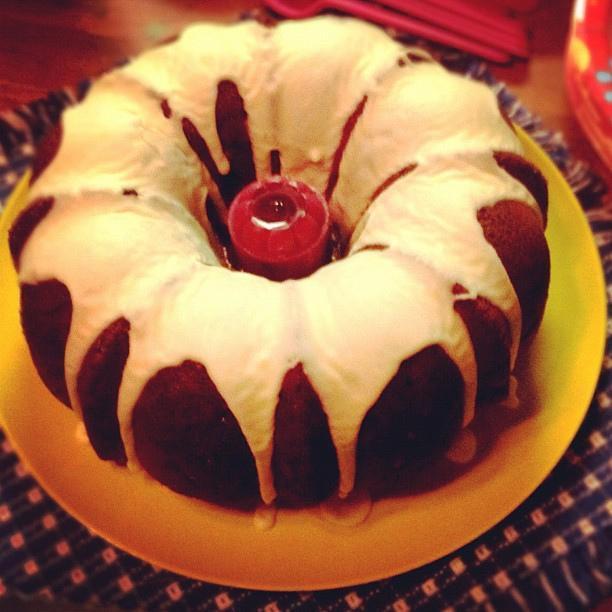How many bottles can you see?
Give a very brief answer. 0. 